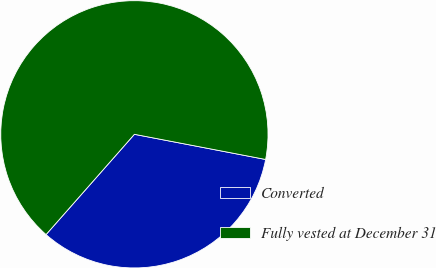Convert chart to OTSL. <chart><loc_0><loc_0><loc_500><loc_500><pie_chart><fcel>Converted<fcel>Fully vested at December 31<nl><fcel>33.48%<fcel>66.52%<nl></chart> 